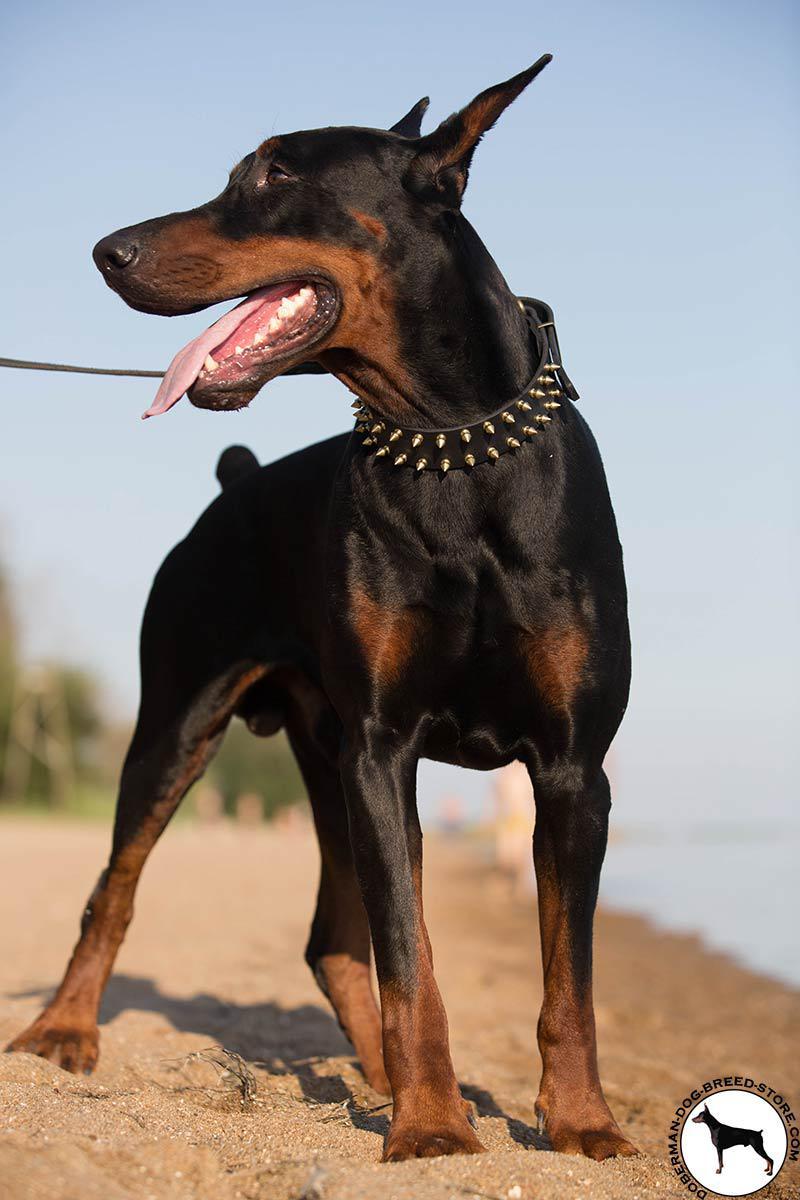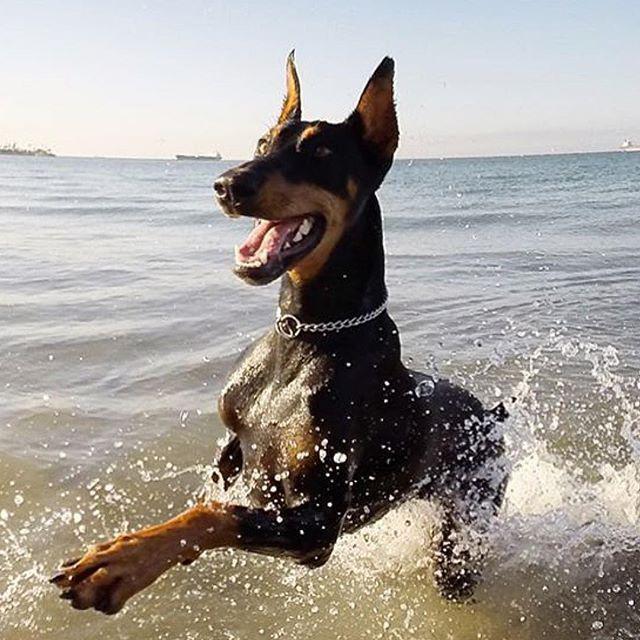The first image is the image on the left, the second image is the image on the right. Examine the images to the left and right. Is the description "Only one dog has a collar on" accurate? Answer yes or no. No. The first image is the image on the left, the second image is the image on the right. Considering the images on both sides, is "All dogs gaze leftward and are dobermans with erect ears, and one dog has its mouth open and tongue hanging past its lower lip." valid? Answer yes or no. Yes. 